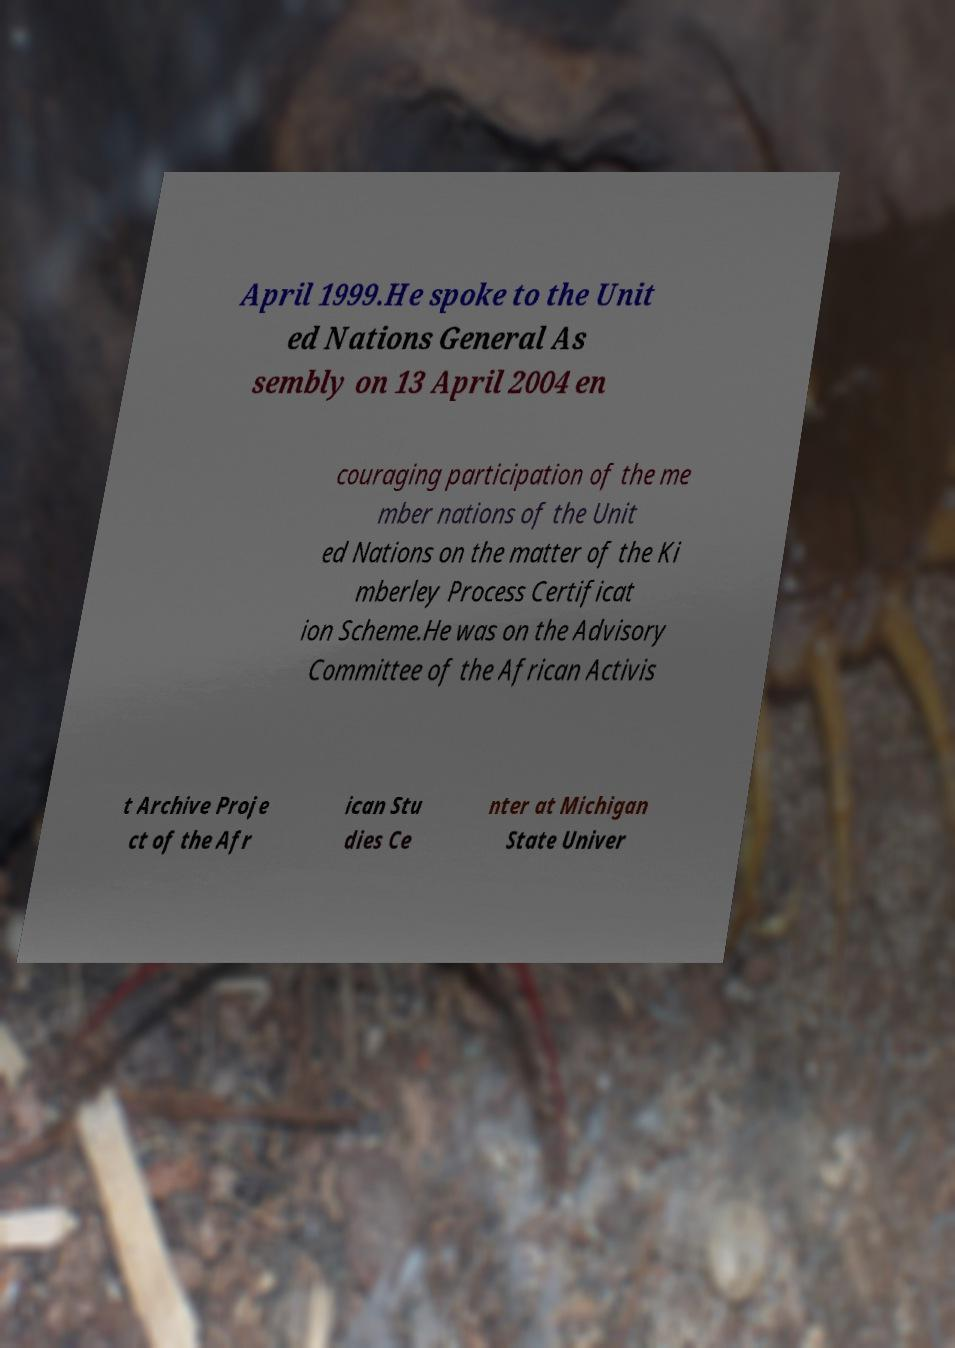Can you read and provide the text displayed in the image?This photo seems to have some interesting text. Can you extract and type it out for me? April 1999.He spoke to the Unit ed Nations General As sembly on 13 April 2004 en couraging participation of the me mber nations of the Unit ed Nations on the matter of the Ki mberley Process Certificat ion Scheme.He was on the Advisory Committee of the African Activis t Archive Proje ct of the Afr ican Stu dies Ce nter at Michigan State Univer 